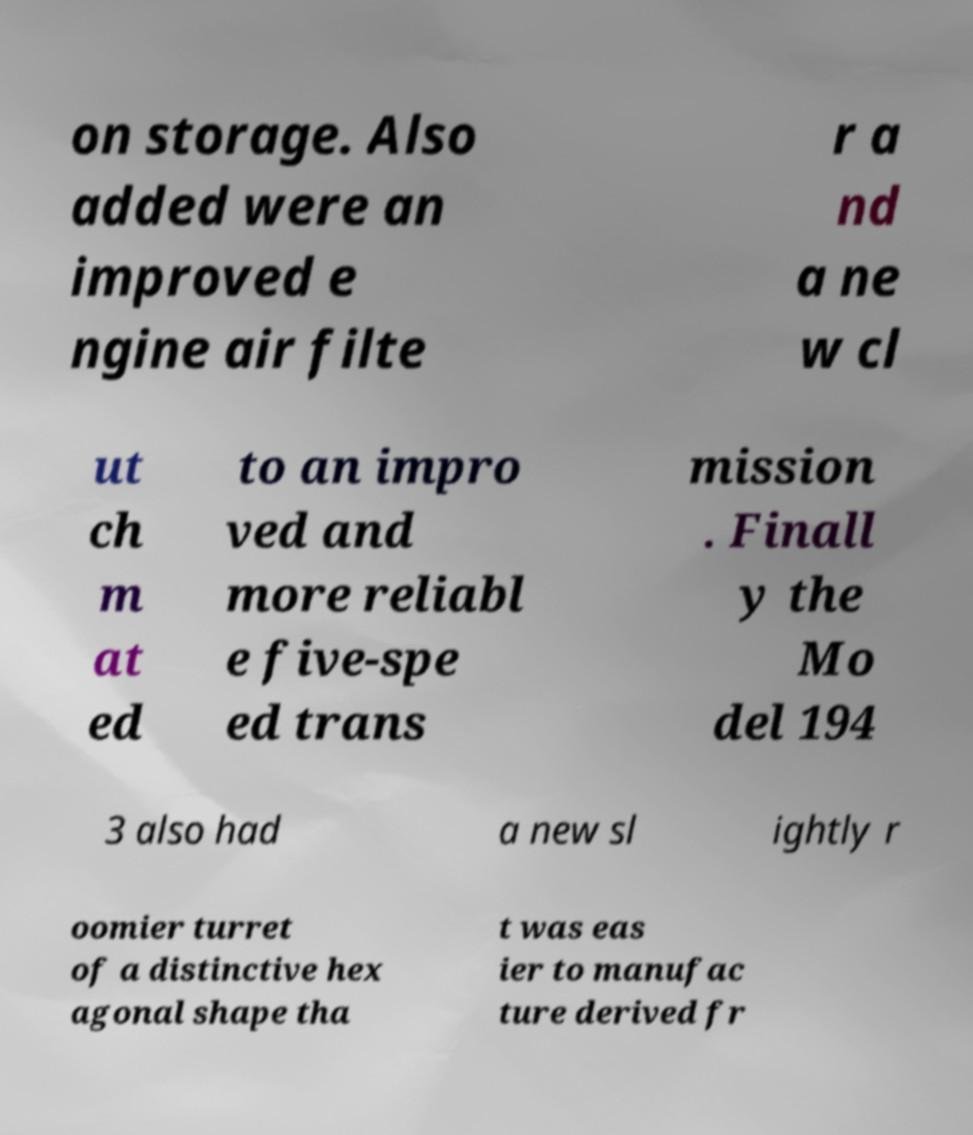Can you accurately transcribe the text from the provided image for me? on storage. Also added were an improved e ngine air filte r a nd a ne w cl ut ch m at ed to an impro ved and more reliabl e five-spe ed trans mission . Finall y the Mo del 194 3 also had a new sl ightly r oomier turret of a distinctive hex agonal shape tha t was eas ier to manufac ture derived fr 